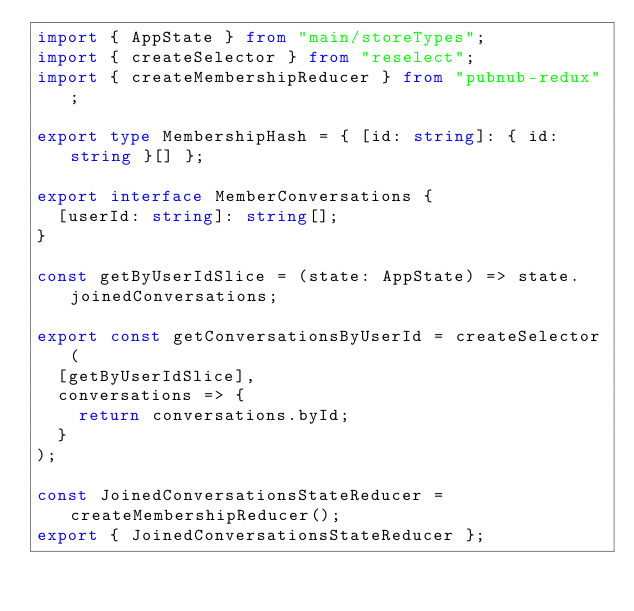Convert code to text. <code><loc_0><loc_0><loc_500><loc_500><_TypeScript_>import { AppState } from "main/storeTypes";
import { createSelector } from "reselect";
import { createMembershipReducer } from "pubnub-redux";

export type MembershipHash = { [id: string]: { id: string }[] };

export interface MemberConversations {
  [userId: string]: string[];
}

const getByUserIdSlice = (state: AppState) => state.joinedConversations;

export const getConversationsByUserId = createSelector(
  [getByUserIdSlice],
  conversations => {
    return conversations.byId;
  }
);

const JoinedConversationsStateReducer = createMembershipReducer();
export { JoinedConversationsStateReducer };
</code> 